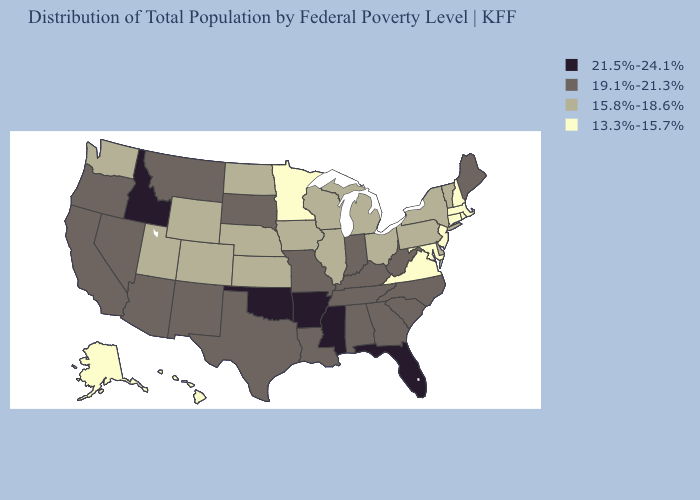Does Virginia have the lowest value in the South?
Keep it brief. Yes. What is the value of Michigan?
Keep it brief. 15.8%-18.6%. Name the states that have a value in the range 13.3%-15.7%?
Short answer required. Alaska, Connecticut, Hawaii, Maryland, Massachusetts, Minnesota, New Hampshire, New Jersey, Rhode Island, Virginia. Does Washington have a lower value than Kentucky?
Short answer required. Yes. Which states have the highest value in the USA?
Give a very brief answer. Arkansas, Florida, Idaho, Mississippi, Oklahoma. What is the value of Arizona?
Short answer required. 19.1%-21.3%. Which states hav the highest value in the South?
Be succinct. Arkansas, Florida, Mississippi, Oklahoma. Does Mississippi have the highest value in the USA?
Give a very brief answer. Yes. Name the states that have a value in the range 15.8%-18.6%?
Answer briefly. Colorado, Delaware, Illinois, Iowa, Kansas, Michigan, Nebraska, New York, North Dakota, Ohio, Pennsylvania, Utah, Vermont, Washington, Wisconsin, Wyoming. Which states have the lowest value in the MidWest?
Short answer required. Minnesota. What is the value of Arizona?
Keep it brief. 19.1%-21.3%. What is the value of New Jersey?
Give a very brief answer. 13.3%-15.7%. Which states have the lowest value in the USA?
Quick response, please. Alaska, Connecticut, Hawaii, Maryland, Massachusetts, Minnesota, New Hampshire, New Jersey, Rhode Island, Virginia. Name the states that have a value in the range 19.1%-21.3%?
Answer briefly. Alabama, Arizona, California, Georgia, Indiana, Kentucky, Louisiana, Maine, Missouri, Montana, Nevada, New Mexico, North Carolina, Oregon, South Carolina, South Dakota, Tennessee, Texas, West Virginia. Among the states that border Georgia , does Florida have the highest value?
Give a very brief answer. Yes. 